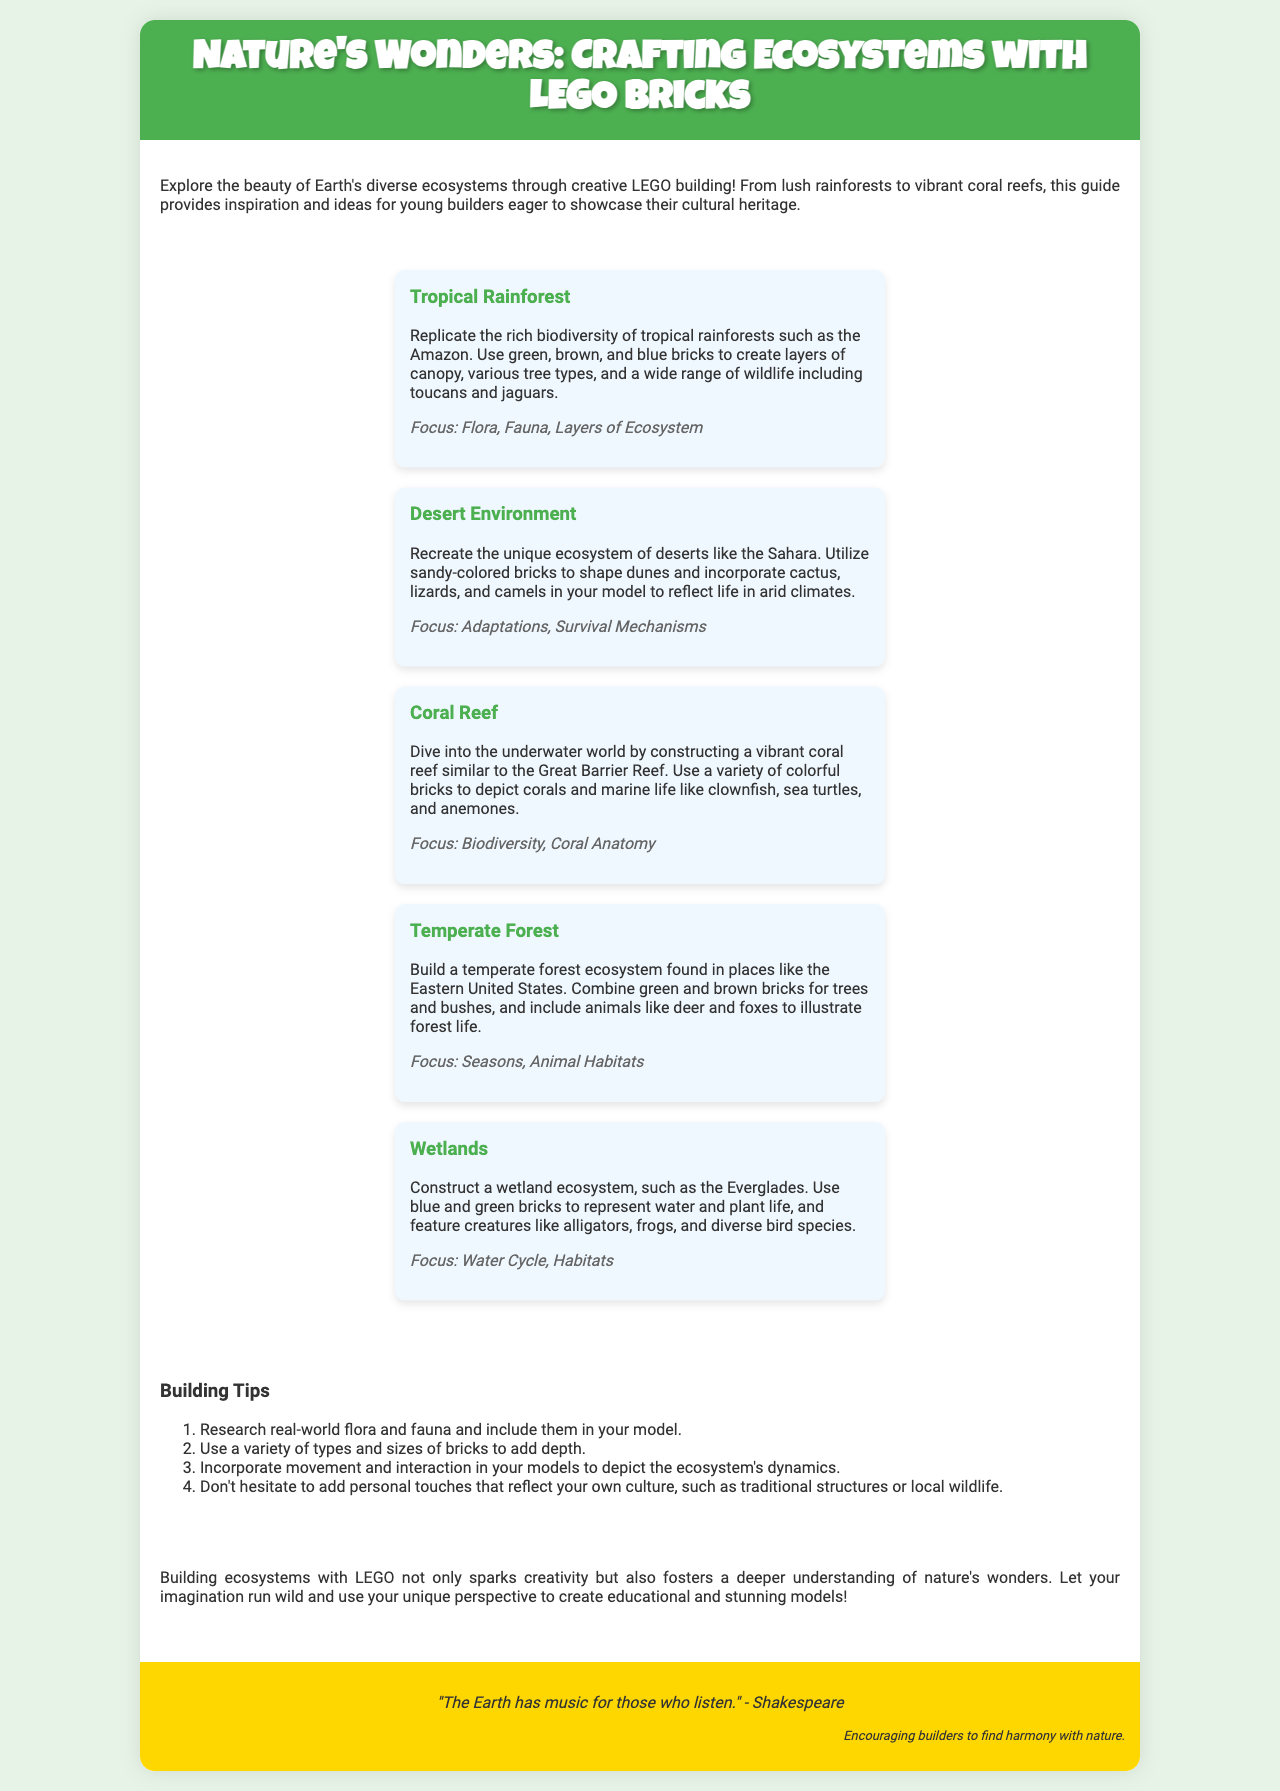What is the title of the brochure? The title of the brochure is prominently displayed at the top of the document.
Answer: Nature's Wonders: Crafting Ecosystems with LEGO Bricks How many ecosystems are featured in the brochure? The brochure lists five distinct ecosystems that builders can recreate with LEGO bricks.
Answer: Five Which ecosystem focuses on biodiversity and coral anatomy? The specific ecosystem related to biodiversity and coral anatomy is mentioned in the description section.
Answer: Coral Reef What is one building tip mentioned in the brochure? The brochure provides several tips for builders, focusing on improving their LEGO models.
Answer: Research real-world flora and fauna What color bricks are suggested for constructing a desert environment? The brochure describes the colors to use for different ecosystems, including the desert.
Answer: Sandy-colored bricks What animal is suggested to be included in a temperate forest model? The temperate forest ecosystem description highlights a specific animal that should be represented.
Answer: Deer What does the quote at the end of the brochure refer to? The quote is included to provide an inspiring message related to nature and creativity in building.
Answer: Harmony with nature Which LEGO ecosystem features alligators and frogs? This question refers to a specific ecosystem and its associated wildlife as described in the brochure.
Answer: Wetlands 